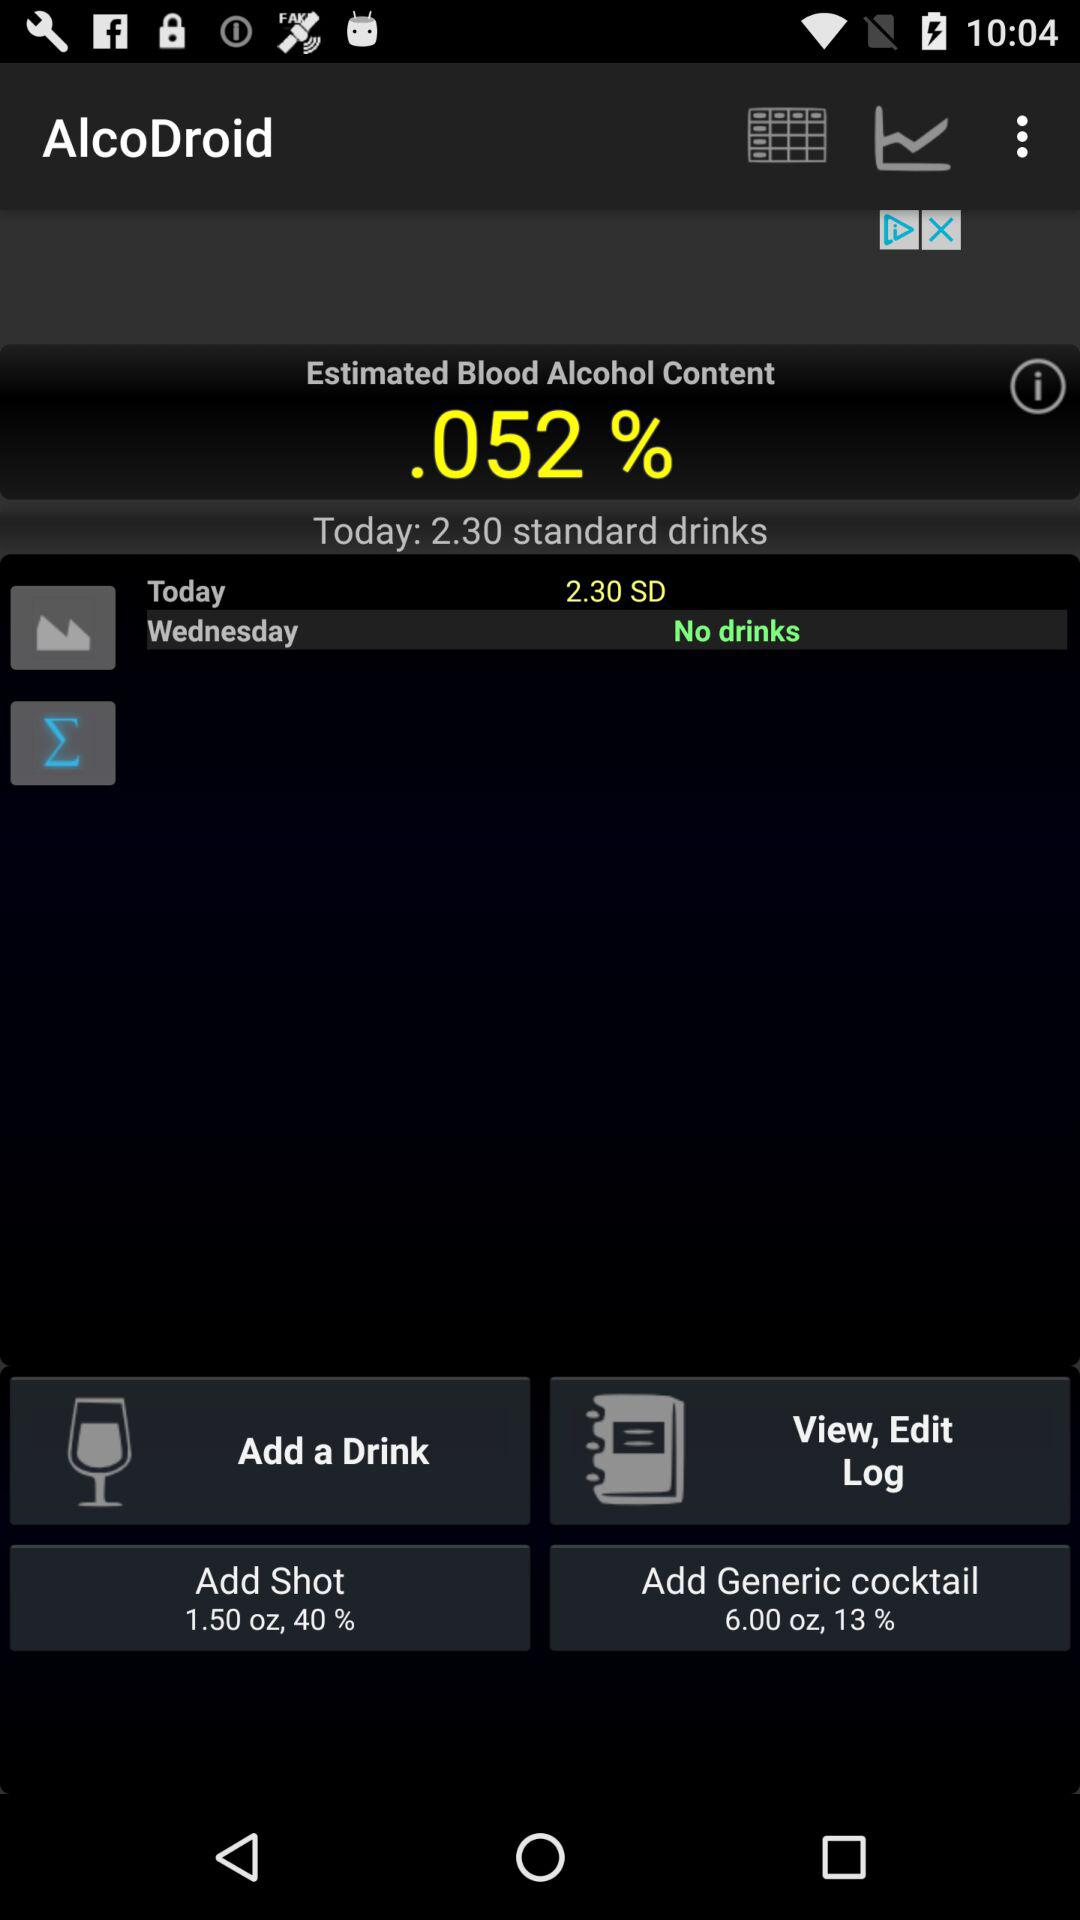Are there any 2.30 standard drinks for today? There are no 2.30 standard drinks for today. 